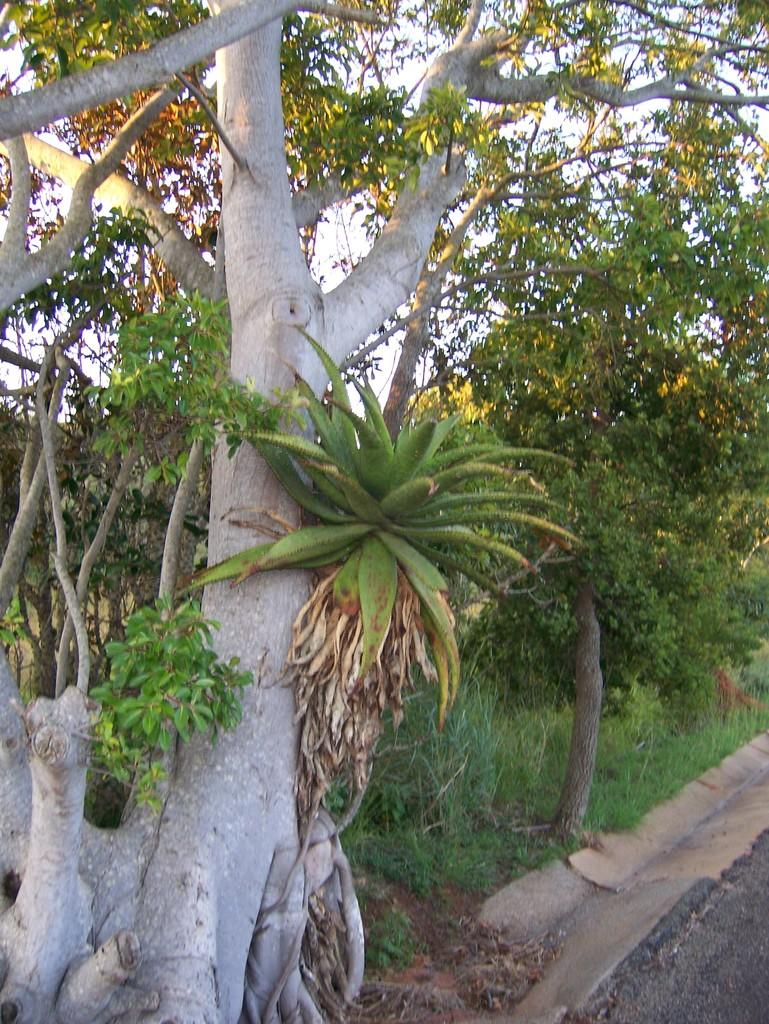What type of vegetation can be seen in the image? There are trees in the image. What is covering the ground in the image? There is grass on the ground in the image. What is the result of adding 2 and 37 in the image? There is no mathematical operation or result visible in the image. What type of animal can be seen interacting with the trees in the image? There are no animals present in the image; it only features trees and grass. 